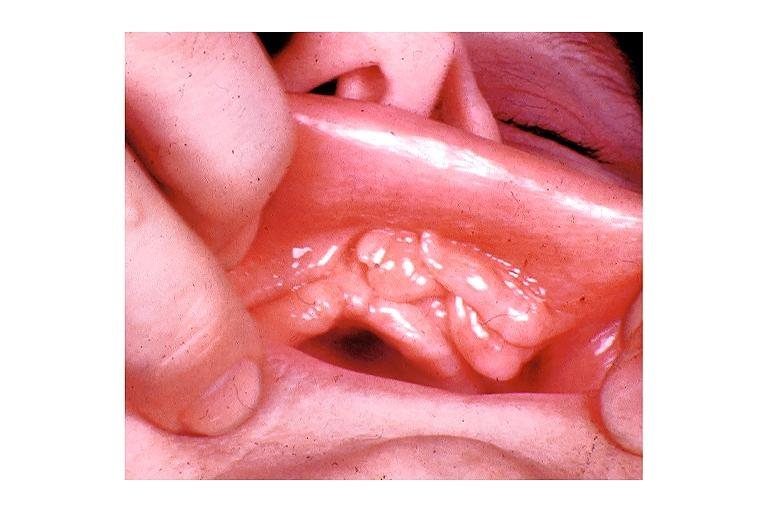s oral present?
Answer the question using a single word or phrase. Yes 